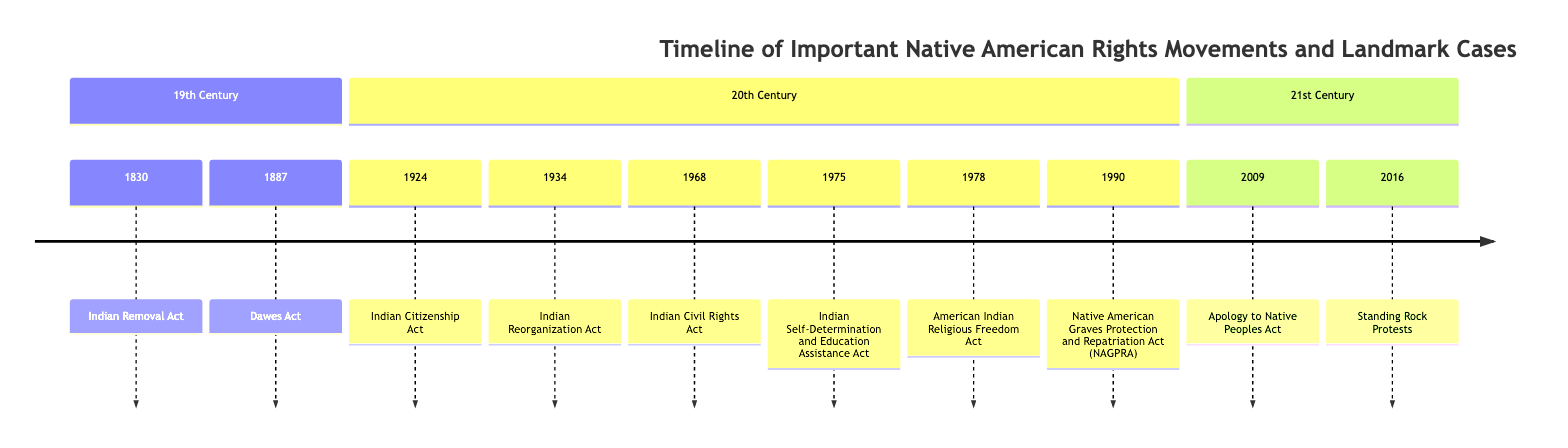What event marked the forced relocation of thousands of Native Americans? The diagram specifies the "Indian Removal Act" in 1830 as the event that led to the forced relocation of thousands of Native Americans.
Answer: Indian Removal Act In what year did the Indian Citizenship Act pass? According to the timeline, the "Indian Citizenship Act" was enacted in 1924.
Answer: 1924 How many acts are listed in the 20th Century section? By counting the events in the 20th Century section of the timeline, there are seven acts recorded.
Answer: 7 Which act aims to protect Native American religious rights? The "American Indian Religious Freedom Act," mentioned in 1978, is specifically aimed at protecting the religious rights of Native Americans.
Answer: American Indian Religious Freedom Act What was a significant outcome of the 2016 Standing Rock Protests? The timeline states that the protests gained "international attention," indicating their significant impact.
Answer: international attention Which act allows tribes to control their education programs? The "Indian Self-Determination and Education Assistance Act," identified in 1975, gives tribes authority over their education programs.
Answer: Indian Self-Determination and Education Assistance Act What event occurred immediately before the apology issued to Native peoples? The timeline indicates that the "Apology to Native Peoples Act" was passed in 2009, following the events listed prior to it, specifically the "Native American Graves Protection and Repatriation Act" in 1990.
Answer: Native American Graves Protection and Repatriation Act Which act was established to reverse some assimilation policies? The "Indian Reorganization Act" from 1934 is described as a measure to reverse assimilation policies and restore land rights.
Answer: Indian Reorganization Act 